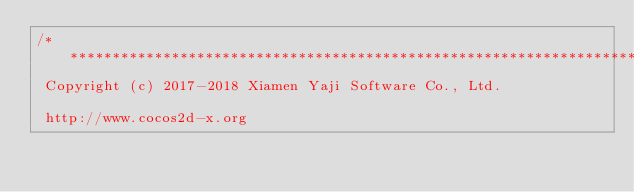<code> <loc_0><loc_0><loc_500><loc_500><_C_>/****************************************************************************
 Copyright (c) 2017-2018 Xiamen Yaji Software Co., Ltd.
 
 http://www.cocos2d-x.org
 </code> 